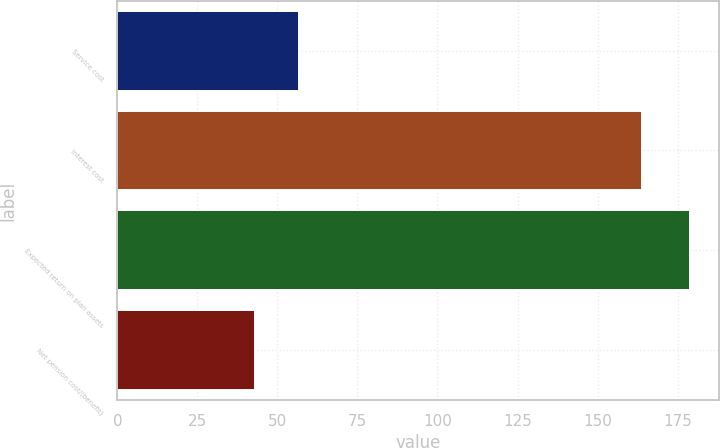Convert chart to OTSL. <chart><loc_0><loc_0><loc_500><loc_500><bar_chart><fcel>Service cost<fcel>Interest cost<fcel>Expected return on plan assets<fcel>Net pension cost/(benefit)<nl><fcel>56.6<fcel>164<fcel>179<fcel>43<nl></chart> 